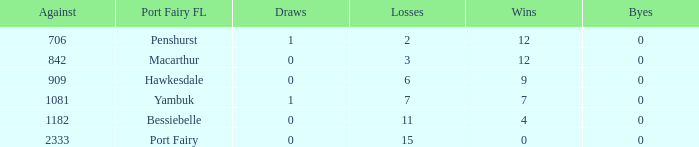I'm looking to parse the entire table for insights. Could you assist me with that? {'header': ['Against', 'Port Fairy FL', 'Draws', 'Losses', 'Wins', 'Byes'], 'rows': [['706', 'Penshurst', '1', '2', '12', '0'], ['842', 'Macarthur', '0', '3', '12', '0'], ['909', 'Hawkesdale', '0', '6', '9', '0'], ['1081', 'Yambuk', '1', '7', '7', '0'], ['1182', 'Bessiebelle', '0', '11', '4', '0'], ['2333', 'Port Fairy', '0', '15', '0', '0']]} How many wins for Port Fairy and against more than 2333? None. 